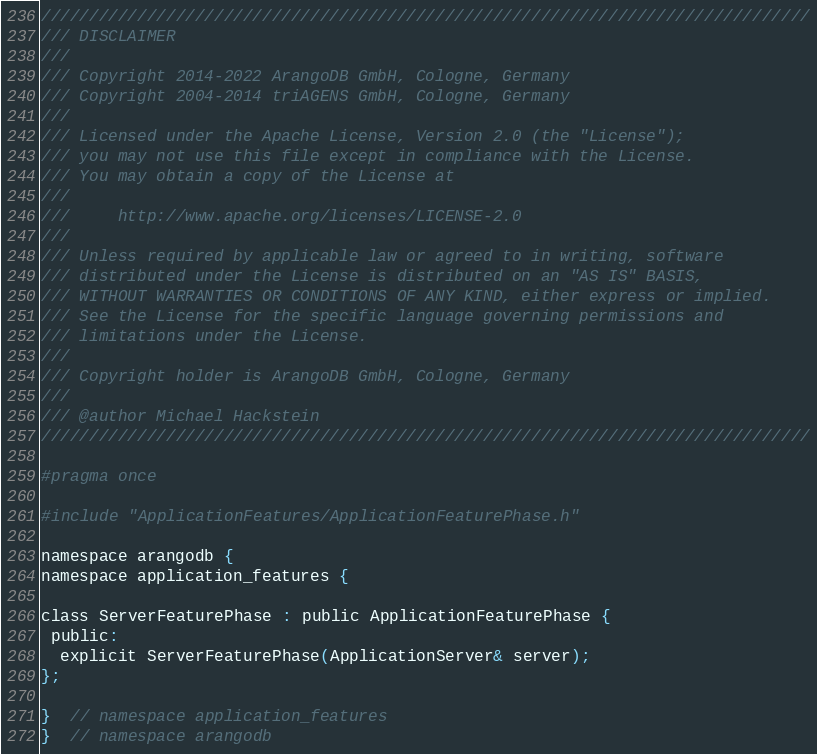<code> <loc_0><loc_0><loc_500><loc_500><_C_>////////////////////////////////////////////////////////////////////////////////
/// DISCLAIMER
///
/// Copyright 2014-2022 ArangoDB GmbH, Cologne, Germany
/// Copyright 2004-2014 triAGENS GmbH, Cologne, Germany
///
/// Licensed under the Apache License, Version 2.0 (the "License");
/// you may not use this file except in compliance with the License.
/// You may obtain a copy of the License at
///
///     http://www.apache.org/licenses/LICENSE-2.0
///
/// Unless required by applicable law or agreed to in writing, software
/// distributed under the License is distributed on an "AS IS" BASIS,
/// WITHOUT WARRANTIES OR CONDITIONS OF ANY KIND, either express or implied.
/// See the License for the specific language governing permissions and
/// limitations under the License.
///
/// Copyright holder is ArangoDB GmbH, Cologne, Germany
///
/// @author Michael Hackstein
////////////////////////////////////////////////////////////////////////////////

#pragma once

#include "ApplicationFeatures/ApplicationFeaturePhase.h"

namespace arangodb {
namespace application_features {

class ServerFeaturePhase : public ApplicationFeaturePhase {
 public:
  explicit ServerFeaturePhase(ApplicationServer& server);
};

}  // namespace application_features
}  // namespace arangodb
</code> 